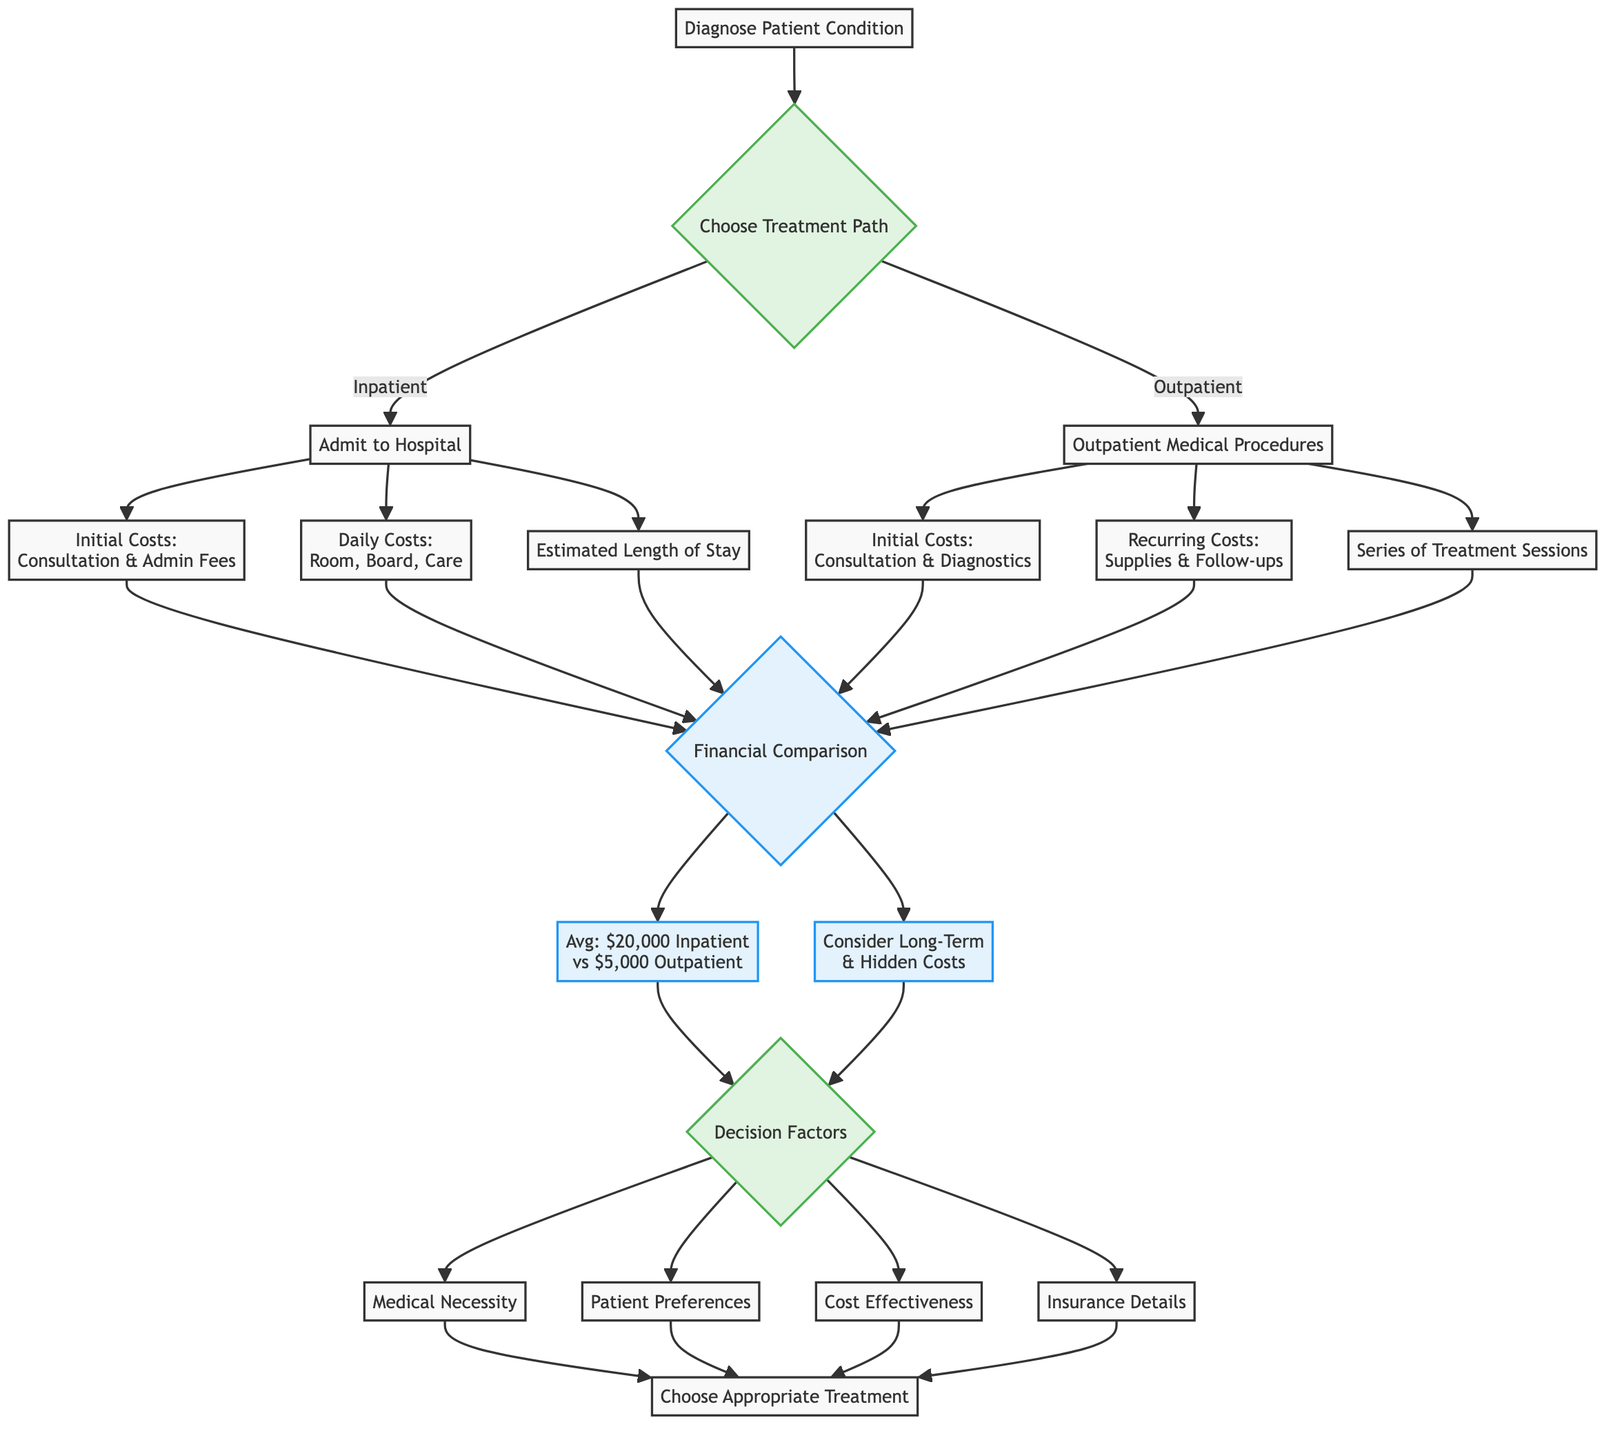What is the initial cost for inpatient treatment? The diagram specifies that the initial cost for inpatient treatment includes "Initial Consultation and Administrative Fees." This is found under the Inpatient Treatment section.
Answer: Initial Consultation and Administrative Fees What are the daily costs associated with inpatient treatment? The diagram indicates that the daily costs for inpatient treatment consist of "Room, Board, Medical Supplies, and Nursing Care." This information is detailed under the Daily Costs of the Inpatient Treatment path.
Answer: Room, Board, Medical Supplies, and Nursing Care What is the average cost comparison between inpatient and outpatient treatments? The Financial Comparison node states the average costs: "$20,000 for Inpatient vs $5,000 for Outpatient." This is a direct comparison shown in the diagram.
Answer: $20,000 for Inpatient vs $5,000 for Outpatient What are two hidden costs associated with inpatient and outpatient treatments? The diagram highlights that inpatient hidden costs may include "family lodging," whereas outpatient hidden costs could involve "transportation." This information is found under Hidden Costs in the Financial Comparison section.
Answer: Family lodging and transportation Which factor is listed first in the Decision Factors? The Decision Factors node lists "Medical Necessity" as the first factor. This is viewed directly in the sequence of nodes stemming from the Decision Factors node.
Answer: Medical Necessity How does the potential financial outcome of outpatient treatment compare regarding costs? The diagram details that the potential financial outcome of outpatient treatment includes "Lower Costs," indicating it generally has lower upfront costs but may accumulate over multiple visits. This comparison is derived from the Outpatient Treatment detailed section.
Answer: Lower Costs What are the two types of costs associated with outpatient treatment? The diagram reports that outpatient treatment has "Initial Costs" and "Recurring Costs." These categories are outlined under the Outpatient Treatment path.
Answer: Initial Costs and Recurring Costs What does the recovery time for inpatient treatment entail? According to the diagram, the potential financial outcome of inpatient treatment includes a longer post-discharge recovery, which may entail subsequent outpatient services. This statement comes from the Potential Financial Outcome under Inpatient Treatment.
Answer: Longer post-discharge recovery What is the medical necessity of a treatment path? The diagram specifies that medical necessity pertains to the "Severity and urgency of the medical condition." This stems from the Decision Factors section which outlines the criteria influencing the choice of treatment.
Answer: Severity and urgency of medical condition 